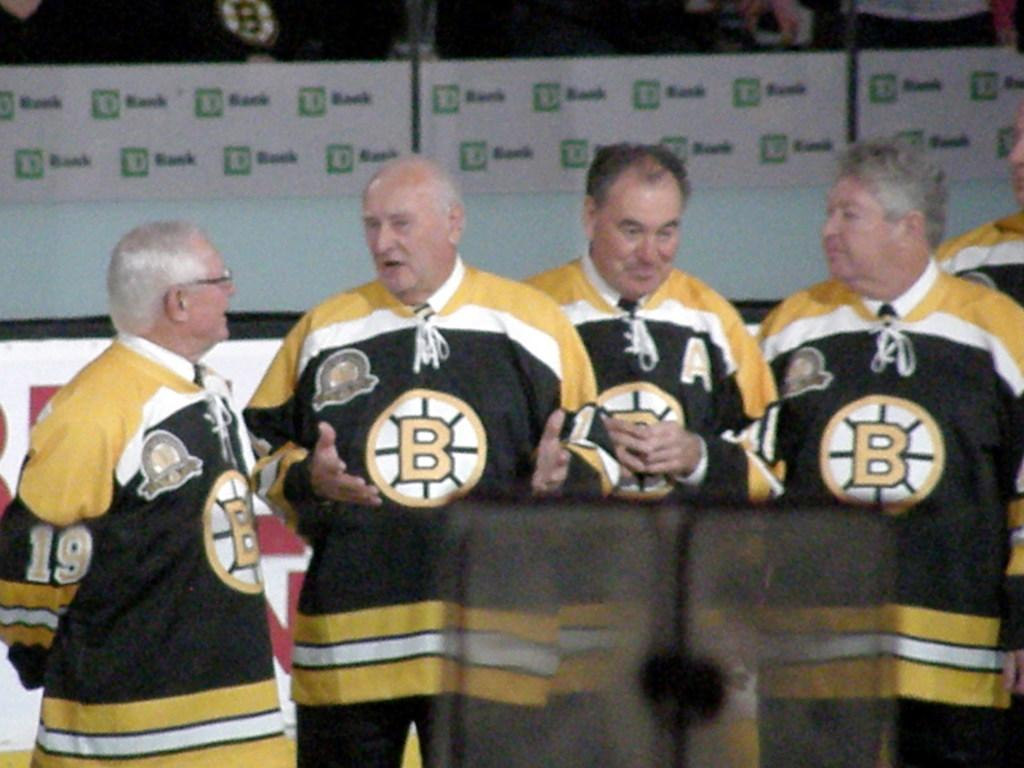<image>
Write a terse but informative summary of the picture. A group of men are wearing matching shirts in front of a sign that says TD Bank. 